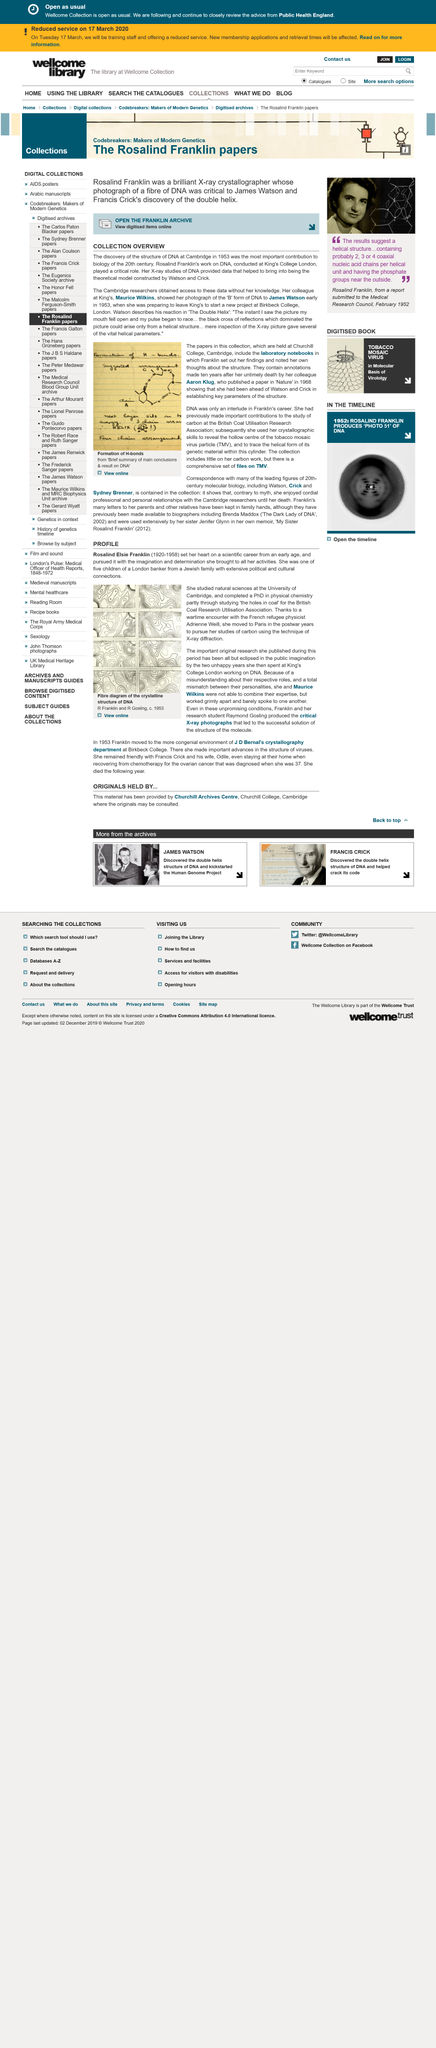Draw attention to some important aspects in this diagram. Rosalind Franklin conducted work on DNA at King's College in London. Maurice Wilkins showed James Watson a photograph of the "B" form of DNA that was taken by Rosalind Franklin. The discovery of the structure of DNA was the most important contribution to biology of the 20th century. 